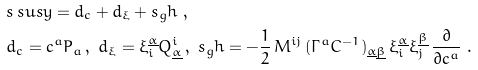Convert formula to latex. <formula><loc_0><loc_0><loc_500><loc_500>& s _ { \, } s u s y = d _ { c } + d _ { \xi } + s _ { g } h \ , \\ & d _ { c } = c ^ { a } P _ { a } \, , \ d _ { \xi } = \xi ^ { \underline { \alpha } } _ { i } Q _ { \underline { \alpha } } ^ { i } \, , \ s _ { g } h = - \frac { 1 } { 2 } \, M ^ { i j } \, ( \Gamma ^ { a } C ^ { - 1 } ) _ { { \underline { \alpha } } { \underline { \beta } } } \, \xi ^ { \underline { \alpha } } _ { i } \xi ^ { \underline { \beta } } _ { j } \, \frac { \partial } { \partial c ^ { a } } \ .</formula> 